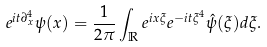<formula> <loc_0><loc_0><loc_500><loc_500>e ^ { i t \partial _ { x } ^ { 4 } } \psi ( x ) = \frac { 1 } { 2 \pi } \int _ { \mathbb { R } } e ^ { i x \xi } e ^ { - i t \xi ^ { 4 } } \hat { \psi } ( \xi ) d \xi .</formula> 